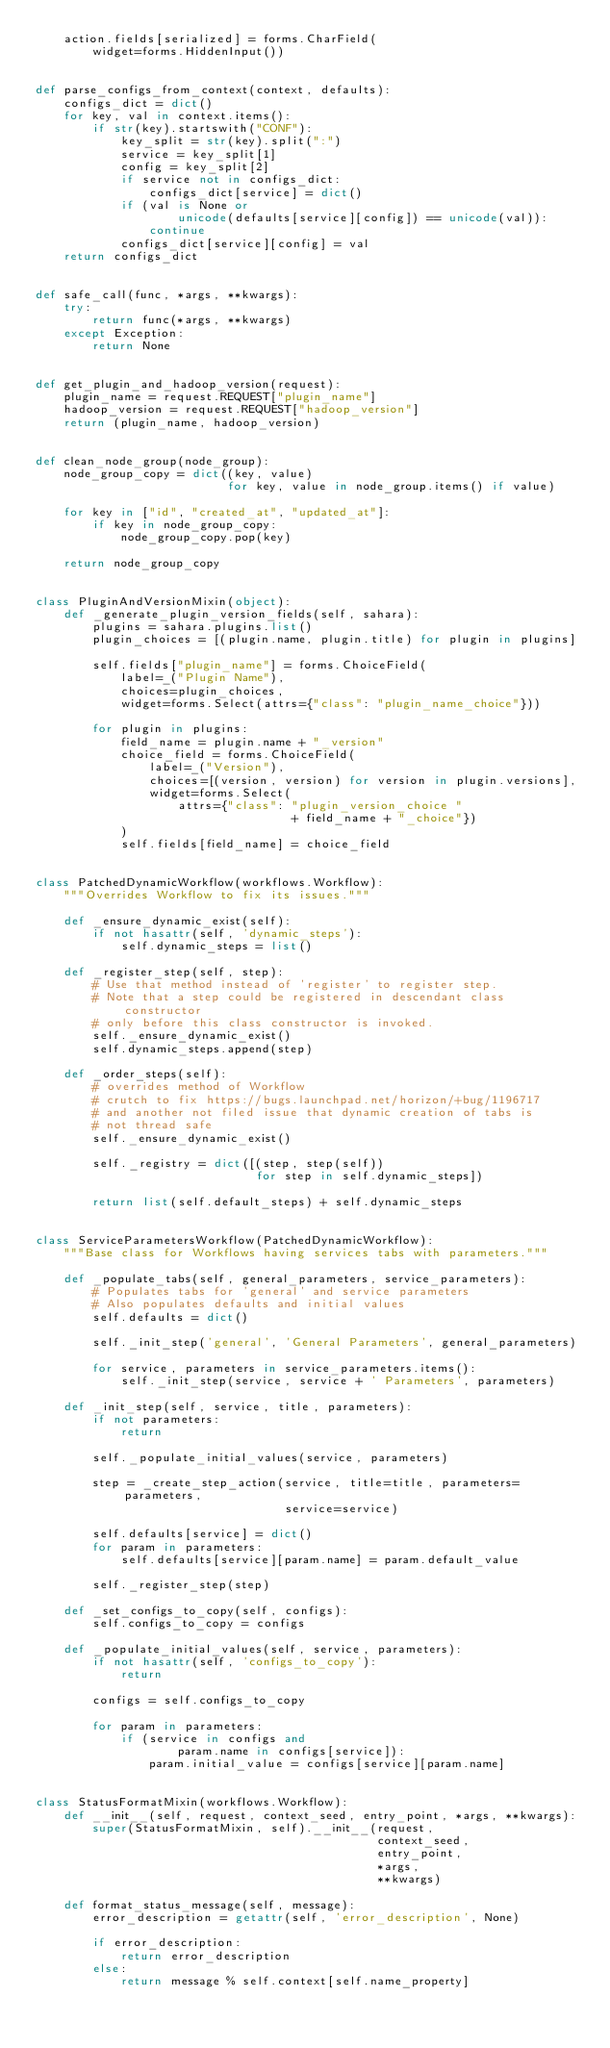<code> <loc_0><loc_0><loc_500><loc_500><_Python_>    action.fields[serialized] = forms.CharField(
        widget=forms.HiddenInput())


def parse_configs_from_context(context, defaults):
    configs_dict = dict()
    for key, val in context.items():
        if str(key).startswith("CONF"):
            key_split = str(key).split(":")
            service = key_split[1]
            config = key_split[2]
            if service not in configs_dict:
                configs_dict[service] = dict()
            if (val is None or
                    unicode(defaults[service][config]) == unicode(val)):
                continue
            configs_dict[service][config] = val
    return configs_dict


def safe_call(func, *args, **kwargs):
    try:
        return func(*args, **kwargs)
    except Exception:
        return None


def get_plugin_and_hadoop_version(request):
    plugin_name = request.REQUEST["plugin_name"]
    hadoop_version = request.REQUEST["hadoop_version"]
    return (plugin_name, hadoop_version)


def clean_node_group(node_group):
    node_group_copy = dict((key, value)
                           for key, value in node_group.items() if value)

    for key in ["id", "created_at", "updated_at"]:
        if key in node_group_copy:
            node_group_copy.pop(key)

    return node_group_copy


class PluginAndVersionMixin(object):
    def _generate_plugin_version_fields(self, sahara):
        plugins = sahara.plugins.list()
        plugin_choices = [(plugin.name, plugin.title) for plugin in plugins]

        self.fields["plugin_name"] = forms.ChoiceField(
            label=_("Plugin Name"),
            choices=plugin_choices,
            widget=forms.Select(attrs={"class": "plugin_name_choice"}))

        for plugin in plugins:
            field_name = plugin.name + "_version"
            choice_field = forms.ChoiceField(
                label=_("Version"),
                choices=[(version, version) for version in plugin.versions],
                widget=forms.Select(
                    attrs={"class": "plugin_version_choice "
                                    + field_name + "_choice"})
            )
            self.fields[field_name] = choice_field


class PatchedDynamicWorkflow(workflows.Workflow):
    """Overrides Workflow to fix its issues."""

    def _ensure_dynamic_exist(self):
        if not hasattr(self, 'dynamic_steps'):
            self.dynamic_steps = list()

    def _register_step(self, step):
        # Use that method instead of 'register' to register step.
        # Note that a step could be registered in descendant class constructor
        # only before this class constructor is invoked.
        self._ensure_dynamic_exist()
        self.dynamic_steps.append(step)

    def _order_steps(self):
        # overrides method of Workflow
        # crutch to fix https://bugs.launchpad.net/horizon/+bug/1196717
        # and another not filed issue that dynamic creation of tabs is
        # not thread safe
        self._ensure_dynamic_exist()

        self._registry = dict([(step, step(self))
                               for step in self.dynamic_steps])

        return list(self.default_steps) + self.dynamic_steps


class ServiceParametersWorkflow(PatchedDynamicWorkflow):
    """Base class for Workflows having services tabs with parameters."""

    def _populate_tabs(self, general_parameters, service_parameters):
        # Populates tabs for 'general' and service parameters
        # Also populates defaults and initial values
        self.defaults = dict()

        self._init_step('general', 'General Parameters', general_parameters)

        for service, parameters in service_parameters.items():
            self._init_step(service, service + ' Parameters', parameters)

    def _init_step(self, service, title, parameters):
        if not parameters:
            return

        self._populate_initial_values(service, parameters)

        step = _create_step_action(service, title=title, parameters=parameters,
                                   service=service)

        self.defaults[service] = dict()
        for param in parameters:
            self.defaults[service][param.name] = param.default_value

        self._register_step(step)

    def _set_configs_to_copy(self, configs):
        self.configs_to_copy = configs

    def _populate_initial_values(self, service, parameters):
        if not hasattr(self, 'configs_to_copy'):
            return

        configs = self.configs_to_copy

        for param in parameters:
            if (service in configs and
                    param.name in configs[service]):
                param.initial_value = configs[service][param.name]


class StatusFormatMixin(workflows.Workflow):
    def __init__(self, request, context_seed, entry_point, *args, **kwargs):
        super(StatusFormatMixin, self).__init__(request,
                                                context_seed,
                                                entry_point,
                                                *args,
                                                **kwargs)

    def format_status_message(self, message):
        error_description = getattr(self, 'error_description', None)

        if error_description:
            return error_description
        else:
            return message % self.context[self.name_property]
</code> 